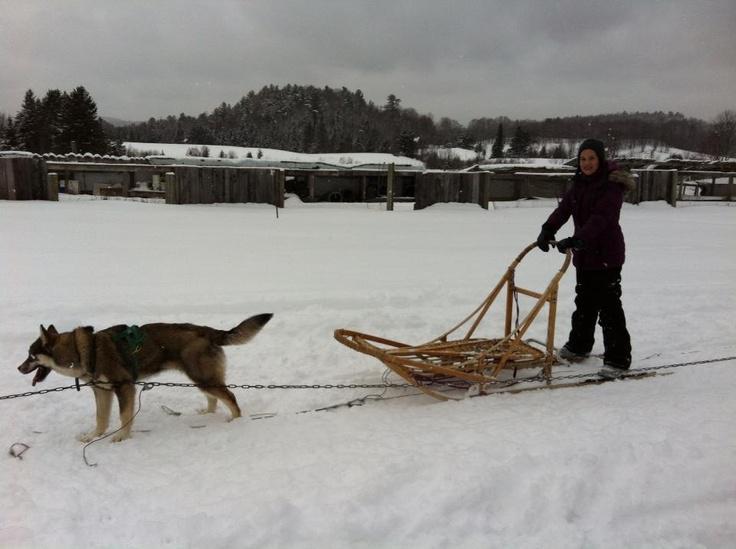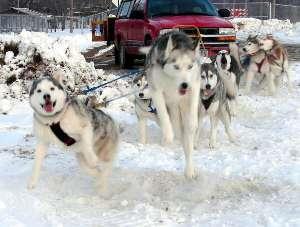The first image is the image on the left, the second image is the image on the right. For the images shown, is this caption "The exterior of a motorized vehicle is visible behind sled dogs in at least one image." true? Answer yes or no. Yes. The first image is the image on the left, the second image is the image on the right. Assess this claim about the two images: "An SUV can be seen in the background on at least one of the images.". Correct or not? Answer yes or no. Yes. 